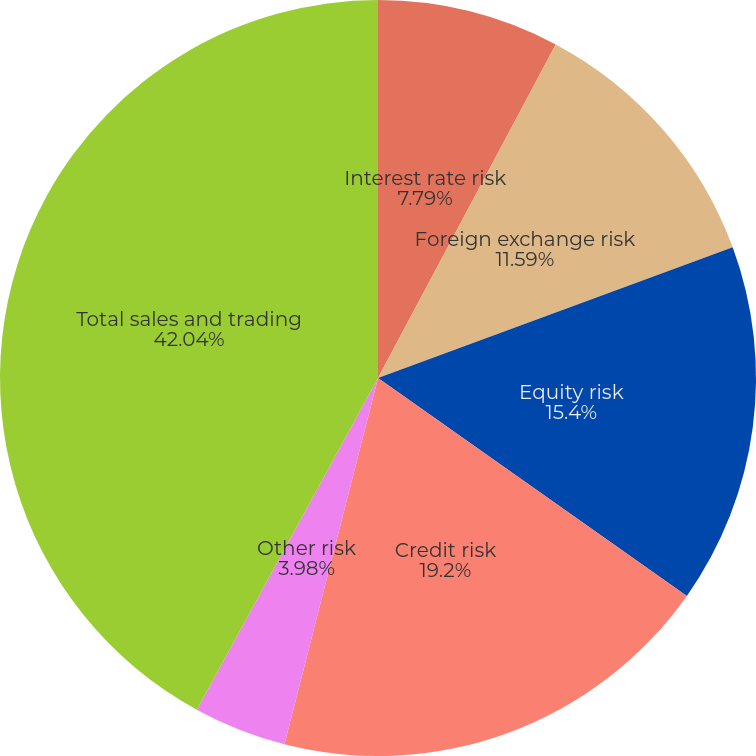Convert chart to OTSL. <chart><loc_0><loc_0><loc_500><loc_500><pie_chart><fcel>Interest rate risk<fcel>Foreign exchange risk<fcel>Equity risk<fcel>Credit risk<fcel>Other risk<fcel>Total sales and trading<nl><fcel>7.79%<fcel>11.59%<fcel>15.4%<fcel>19.2%<fcel>3.98%<fcel>42.04%<nl></chart> 